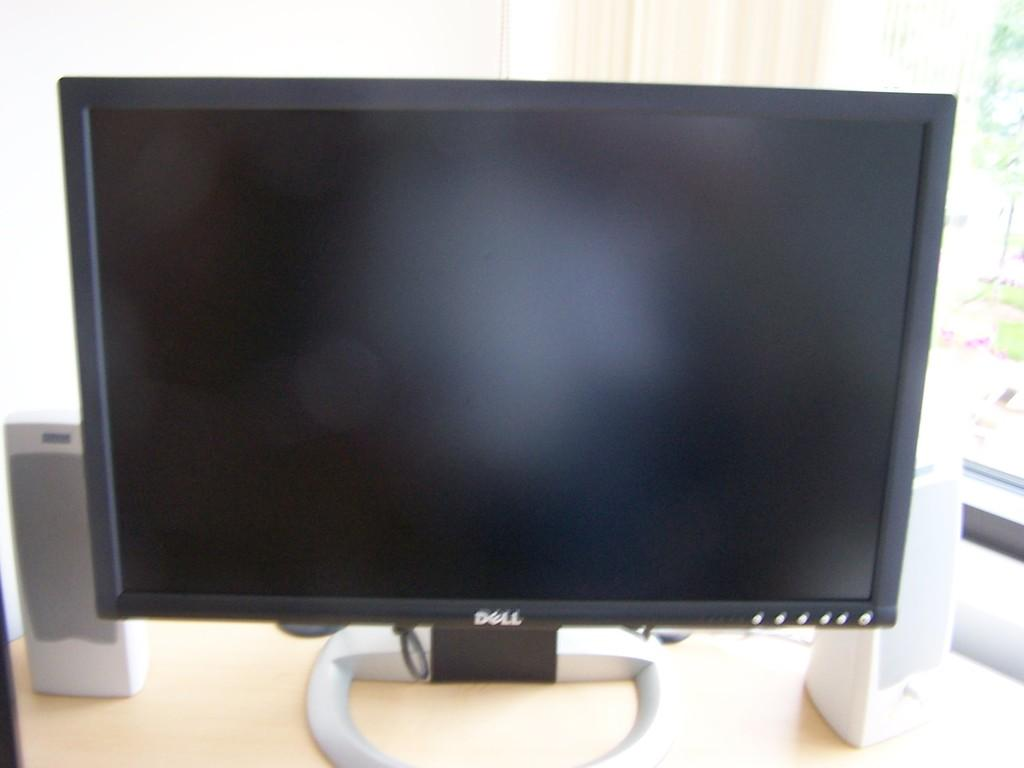What type of furniture is visible in the image? There is a desktop in the image. What electronic devices are present on the table in the image? There are two speakers on a table in the image. What can be seen in the background of the image? There is a window in the background of the image. What is covering the window in the image? There is a curtain in front of the window. How many apples are on the desktop in the image? There are no apples present on the desktop in the image. What type of music is being played from the speakers in the image? There is no indication of music being played in the image, as it only shows the speakers and not any audio source. 